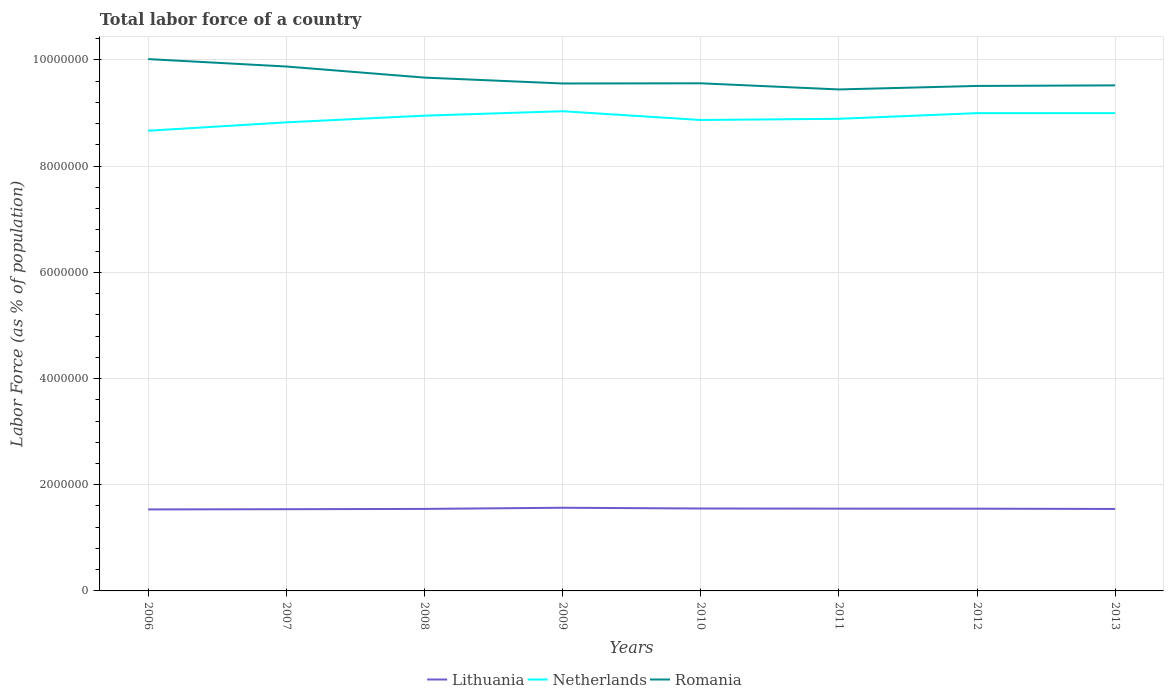Is the number of lines equal to the number of legend labels?
Give a very brief answer. Yes. Across all years, what is the maximum percentage of labor force in Netherlands?
Offer a very short reply. 8.67e+06. In which year was the percentage of labor force in Romania maximum?
Ensure brevity in your answer.  2011. What is the total percentage of labor force in Netherlands in the graph?
Offer a very short reply. 3.59e+04. What is the difference between the highest and the second highest percentage of labor force in Netherlands?
Provide a short and direct response. 3.68e+05. How many lines are there?
Your answer should be very brief. 3. What is the difference between two consecutive major ticks on the Y-axis?
Give a very brief answer. 2.00e+06. Are the values on the major ticks of Y-axis written in scientific E-notation?
Offer a very short reply. No. How many legend labels are there?
Ensure brevity in your answer.  3. How are the legend labels stacked?
Ensure brevity in your answer.  Horizontal. What is the title of the graph?
Keep it short and to the point. Total labor force of a country. What is the label or title of the X-axis?
Your answer should be compact. Years. What is the label or title of the Y-axis?
Your answer should be compact. Labor Force (as % of population). What is the Labor Force (as % of population) of Lithuania in 2006?
Keep it short and to the point. 1.53e+06. What is the Labor Force (as % of population) in Netherlands in 2006?
Give a very brief answer. 8.67e+06. What is the Labor Force (as % of population) in Romania in 2006?
Your answer should be very brief. 1.00e+07. What is the Labor Force (as % of population) of Lithuania in 2007?
Provide a succinct answer. 1.54e+06. What is the Labor Force (as % of population) of Netherlands in 2007?
Offer a terse response. 8.82e+06. What is the Labor Force (as % of population) in Romania in 2007?
Ensure brevity in your answer.  9.88e+06. What is the Labor Force (as % of population) in Lithuania in 2008?
Your answer should be very brief. 1.54e+06. What is the Labor Force (as % of population) of Netherlands in 2008?
Offer a very short reply. 8.95e+06. What is the Labor Force (as % of population) in Romania in 2008?
Make the answer very short. 9.67e+06. What is the Labor Force (as % of population) of Lithuania in 2009?
Your answer should be very brief. 1.57e+06. What is the Labor Force (as % of population) of Netherlands in 2009?
Ensure brevity in your answer.  9.03e+06. What is the Labor Force (as % of population) of Romania in 2009?
Provide a succinct answer. 9.56e+06. What is the Labor Force (as % of population) of Lithuania in 2010?
Keep it short and to the point. 1.55e+06. What is the Labor Force (as % of population) of Netherlands in 2010?
Your answer should be very brief. 8.87e+06. What is the Labor Force (as % of population) of Romania in 2010?
Your answer should be compact. 9.56e+06. What is the Labor Force (as % of population) in Lithuania in 2011?
Ensure brevity in your answer.  1.55e+06. What is the Labor Force (as % of population) in Netherlands in 2011?
Provide a succinct answer. 8.89e+06. What is the Labor Force (as % of population) in Romania in 2011?
Provide a succinct answer. 9.44e+06. What is the Labor Force (as % of population) of Lithuania in 2012?
Your answer should be compact. 1.55e+06. What is the Labor Force (as % of population) in Netherlands in 2012?
Your answer should be compact. 9.00e+06. What is the Labor Force (as % of population) in Romania in 2012?
Ensure brevity in your answer.  9.51e+06. What is the Labor Force (as % of population) in Lithuania in 2013?
Offer a very short reply. 1.54e+06. What is the Labor Force (as % of population) of Netherlands in 2013?
Ensure brevity in your answer.  9.00e+06. What is the Labor Force (as % of population) of Romania in 2013?
Ensure brevity in your answer.  9.52e+06. Across all years, what is the maximum Labor Force (as % of population) of Lithuania?
Keep it short and to the point. 1.57e+06. Across all years, what is the maximum Labor Force (as % of population) of Netherlands?
Offer a terse response. 9.03e+06. Across all years, what is the maximum Labor Force (as % of population) in Romania?
Your answer should be compact. 1.00e+07. Across all years, what is the minimum Labor Force (as % of population) of Lithuania?
Your answer should be very brief. 1.53e+06. Across all years, what is the minimum Labor Force (as % of population) of Netherlands?
Ensure brevity in your answer.  8.67e+06. Across all years, what is the minimum Labor Force (as % of population) in Romania?
Ensure brevity in your answer.  9.44e+06. What is the total Labor Force (as % of population) in Lithuania in the graph?
Offer a terse response. 1.24e+07. What is the total Labor Force (as % of population) in Netherlands in the graph?
Your answer should be very brief. 7.12e+07. What is the total Labor Force (as % of population) of Romania in the graph?
Make the answer very short. 7.72e+07. What is the difference between the Labor Force (as % of population) of Lithuania in 2006 and that in 2007?
Provide a short and direct response. -4175. What is the difference between the Labor Force (as % of population) in Netherlands in 2006 and that in 2007?
Offer a very short reply. -1.58e+05. What is the difference between the Labor Force (as % of population) of Romania in 2006 and that in 2007?
Give a very brief answer. 1.40e+05. What is the difference between the Labor Force (as % of population) in Lithuania in 2006 and that in 2008?
Offer a terse response. -9790. What is the difference between the Labor Force (as % of population) in Netherlands in 2006 and that in 2008?
Ensure brevity in your answer.  -2.84e+05. What is the difference between the Labor Force (as % of population) in Romania in 2006 and that in 2008?
Ensure brevity in your answer.  3.48e+05. What is the difference between the Labor Force (as % of population) of Lithuania in 2006 and that in 2009?
Keep it short and to the point. -3.15e+04. What is the difference between the Labor Force (as % of population) in Netherlands in 2006 and that in 2009?
Ensure brevity in your answer.  -3.68e+05. What is the difference between the Labor Force (as % of population) in Romania in 2006 and that in 2009?
Your response must be concise. 4.59e+05. What is the difference between the Labor Force (as % of population) in Lithuania in 2006 and that in 2010?
Provide a short and direct response. -1.74e+04. What is the difference between the Labor Force (as % of population) of Netherlands in 2006 and that in 2010?
Keep it short and to the point. -2.03e+05. What is the difference between the Labor Force (as % of population) of Romania in 2006 and that in 2010?
Provide a succinct answer. 4.56e+05. What is the difference between the Labor Force (as % of population) in Lithuania in 2006 and that in 2011?
Make the answer very short. -1.46e+04. What is the difference between the Labor Force (as % of population) in Netherlands in 2006 and that in 2011?
Keep it short and to the point. -2.25e+05. What is the difference between the Labor Force (as % of population) in Romania in 2006 and that in 2011?
Provide a short and direct response. 5.72e+05. What is the difference between the Labor Force (as % of population) of Lithuania in 2006 and that in 2012?
Make the answer very short. -1.38e+04. What is the difference between the Labor Force (as % of population) of Netherlands in 2006 and that in 2012?
Give a very brief answer. -3.32e+05. What is the difference between the Labor Force (as % of population) of Romania in 2006 and that in 2012?
Make the answer very short. 5.06e+05. What is the difference between the Labor Force (as % of population) of Lithuania in 2006 and that in 2013?
Provide a succinct answer. -8868. What is the difference between the Labor Force (as % of population) in Netherlands in 2006 and that in 2013?
Keep it short and to the point. -3.32e+05. What is the difference between the Labor Force (as % of population) in Romania in 2006 and that in 2013?
Offer a very short reply. 4.95e+05. What is the difference between the Labor Force (as % of population) in Lithuania in 2007 and that in 2008?
Give a very brief answer. -5615. What is the difference between the Labor Force (as % of population) in Netherlands in 2007 and that in 2008?
Your answer should be compact. -1.26e+05. What is the difference between the Labor Force (as % of population) of Romania in 2007 and that in 2008?
Your response must be concise. 2.09e+05. What is the difference between the Labor Force (as % of population) in Lithuania in 2007 and that in 2009?
Your answer should be very brief. -2.74e+04. What is the difference between the Labor Force (as % of population) in Netherlands in 2007 and that in 2009?
Your answer should be very brief. -2.10e+05. What is the difference between the Labor Force (as % of population) in Romania in 2007 and that in 2009?
Keep it short and to the point. 3.20e+05. What is the difference between the Labor Force (as % of population) of Lithuania in 2007 and that in 2010?
Your answer should be compact. -1.32e+04. What is the difference between the Labor Force (as % of population) in Netherlands in 2007 and that in 2010?
Offer a terse response. -4.43e+04. What is the difference between the Labor Force (as % of population) in Romania in 2007 and that in 2010?
Provide a succinct answer. 3.16e+05. What is the difference between the Labor Force (as % of population) in Lithuania in 2007 and that in 2011?
Provide a short and direct response. -1.04e+04. What is the difference between the Labor Force (as % of population) of Netherlands in 2007 and that in 2011?
Make the answer very short. -6.68e+04. What is the difference between the Labor Force (as % of population) in Romania in 2007 and that in 2011?
Give a very brief answer. 4.32e+05. What is the difference between the Labor Force (as % of population) of Lithuania in 2007 and that in 2012?
Give a very brief answer. -9575. What is the difference between the Labor Force (as % of population) of Netherlands in 2007 and that in 2012?
Give a very brief answer. -1.73e+05. What is the difference between the Labor Force (as % of population) in Romania in 2007 and that in 2012?
Offer a very short reply. 3.66e+05. What is the difference between the Labor Force (as % of population) of Lithuania in 2007 and that in 2013?
Offer a very short reply. -4693. What is the difference between the Labor Force (as % of population) of Netherlands in 2007 and that in 2013?
Keep it short and to the point. -1.74e+05. What is the difference between the Labor Force (as % of population) of Romania in 2007 and that in 2013?
Provide a succinct answer. 3.55e+05. What is the difference between the Labor Force (as % of population) in Lithuania in 2008 and that in 2009?
Provide a short and direct response. -2.17e+04. What is the difference between the Labor Force (as % of population) of Netherlands in 2008 and that in 2009?
Ensure brevity in your answer.  -8.38e+04. What is the difference between the Labor Force (as % of population) in Romania in 2008 and that in 2009?
Give a very brief answer. 1.11e+05. What is the difference between the Labor Force (as % of population) of Lithuania in 2008 and that in 2010?
Your answer should be compact. -7584. What is the difference between the Labor Force (as % of population) of Netherlands in 2008 and that in 2010?
Provide a short and direct response. 8.14e+04. What is the difference between the Labor Force (as % of population) of Romania in 2008 and that in 2010?
Your answer should be very brief. 1.08e+05. What is the difference between the Labor Force (as % of population) of Lithuania in 2008 and that in 2011?
Offer a terse response. -4782. What is the difference between the Labor Force (as % of population) of Netherlands in 2008 and that in 2011?
Provide a short and direct response. 5.89e+04. What is the difference between the Labor Force (as % of population) in Romania in 2008 and that in 2011?
Your answer should be compact. 2.23e+05. What is the difference between the Labor Force (as % of population) in Lithuania in 2008 and that in 2012?
Your answer should be compact. -3960. What is the difference between the Labor Force (as % of population) of Netherlands in 2008 and that in 2012?
Your answer should be very brief. -4.76e+04. What is the difference between the Labor Force (as % of population) of Romania in 2008 and that in 2012?
Your response must be concise. 1.57e+05. What is the difference between the Labor Force (as % of population) of Lithuania in 2008 and that in 2013?
Your answer should be very brief. 922. What is the difference between the Labor Force (as % of population) in Netherlands in 2008 and that in 2013?
Give a very brief answer. -4.79e+04. What is the difference between the Labor Force (as % of population) of Romania in 2008 and that in 2013?
Make the answer very short. 1.47e+05. What is the difference between the Labor Force (as % of population) in Lithuania in 2009 and that in 2010?
Ensure brevity in your answer.  1.42e+04. What is the difference between the Labor Force (as % of population) of Netherlands in 2009 and that in 2010?
Offer a very short reply. 1.65e+05. What is the difference between the Labor Force (as % of population) in Romania in 2009 and that in 2010?
Your answer should be very brief. -3468. What is the difference between the Labor Force (as % of population) of Lithuania in 2009 and that in 2011?
Ensure brevity in your answer.  1.70e+04. What is the difference between the Labor Force (as % of population) of Netherlands in 2009 and that in 2011?
Offer a terse response. 1.43e+05. What is the difference between the Labor Force (as % of population) of Romania in 2009 and that in 2011?
Your answer should be compact. 1.12e+05. What is the difference between the Labor Force (as % of population) of Lithuania in 2009 and that in 2012?
Offer a terse response. 1.78e+04. What is the difference between the Labor Force (as % of population) in Netherlands in 2009 and that in 2012?
Provide a succinct answer. 3.62e+04. What is the difference between the Labor Force (as % of population) in Romania in 2009 and that in 2012?
Keep it short and to the point. 4.61e+04. What is the difference between the Labor Force (as % of population) of Lithuania in 2009 and that in 2013?
Your answer should be compact. 2.27e+04. What is the difference between the Labor Force (as % of population) of Netherlands in 2009 and that in 2013?
Offer a very short reply. 3.59e+04. What is the difference between the Labor Force (as % of population) of Romania in 2009 and that in 2013?
Keep it short and to the point. 3.56e+04. What is the difference between the Labor Force (as % of population) in Lithuania in 2010 and that in 2011?
Your response must be concise. 2802. What is the difference between the Labor Force (as % of population) of Netherlands in 2010 and that in 2011?
Give a very brief answer. -2.25e+04. What is the difference between the Labor Force (as % of population) of Romania in 2010 and that in 2011?
Keep it short and to the point. 1.16e+05. What is the difference between the Labor Force (as % of population) of Lithuania in 2010 and that in 2012?
Offer a very short reply. 3624. What is the difference between the Labor Force (as % of population) of Netherlands in 2010 and that in 2012?
Provide a short and direct response. -1.29e+05. What is the difference between the Labor Force (as % of population) of Romania in 2010 and that in 2012?
Keep it short and to the point. 4.96e+04. What is the difference between the Labor Force (as % of population) in Lithuania in 2010 and that in 2013?
Provide a short and direct response. 8506. What is the difference between the Labor Force (as % of population) of Netherlands in 2010 and that in 2013?
Provide a succinct answer. -1.29e+05. What is the difference between the Labor Force (as % of population) of Romania in 2010 and that in 2013?
Your answer should be very brief. 3.90e+04. What is the difference between the Labor Force (as % of population) in Lithuania in 2011 and that in 2012?
Your answer should be compact. 822. What is the difference between the Labor Force (as % of population) of Netherlands in 2011 and that in 2012?
Provide a short and direct response. -1.07e+05. What is the difference between the Labor Force (as % of population) in Romania in 2011 and that in 2012?
Offer a very short reply. -6.60e+04. What is the difference between the Labor Force (as % of population) of Lithuania in 2011 and that in 2013?
Give a very brief answer. 5704. What is the difference between the Labor Force (as % of population) in Netherlands in 2011 and that in 2013?
Give a very brief answer. -1.07e+05. What is the difference between the Labor Force (as % of population) of Romania in 2011 and that in 2013?
Provide a short and direct response. -7.65e+04. What is the difference between the Labor Force (as % of population) in Lithuania in 2012 and that in 2013?
Offer a terse response. 4882. What is the difference between the Labor Force (as % of population) of Netherlands in 2012 and that in 2013?
Offer a very short reply. -260. What is the difference between the Labor Force (as % of population) in Romania in 2012 and that in 2013?
Make the answer very short. -1.06e+04. What is the difference between the Labor Force (as % of population) of Lithuania in 2006 and the Labor Force (as % of population) of Netherlands in 2007?
Your answer should be compact. -7.29e+06. What is the difference between the Labor Force (as % of population) of Lithuania in 2006 and the Labor Force (as % of population) of Romania in 2007?
Offer a terse response. -8.34e+06. What is the difference between the Labor Force (as % of population) of Netherlands in 2006 and the Labor Force (as % of population) of Romania in 2007?
Offer a terse response. -1.21e+06. What is the difference between the Labor Force (as % of population) in Lithuania in 2006 and the Labor Force (as % of population) in Netherlands in 2008?
Provide a short and direct response. -7.42e+06. What is the difference between the Labor Force (as % of population) of Lithuania in 2006 and the Labor Force (as % of population) of Romania in 2008?
Ensure brevity in your answer.  -8.13e+06. What is the difference between the Labor Force (as % of population) of Netherlands in 2006 and the Labor Force (as % of population) of Romania in 2008?
Your response must be concise. -1.00e+06. What is the difference between the Labor Force (as % of population) of Lithuania in 2006 and the Labor Force (as % of population) of Netherlands in 2009?
Provide a short and direct response. -7.50e+06. What is the difference between the Labor Force (as % of population) in Lithuania in 2006 and the Labor Force (as % of population) in Romania in 2009?
Keep it short and to the point. -8.02e+06. What is the difference between the Labor Force (as % of population) in Netherlands in 2006 and the Labor Force (as % of population) in Romania in 2009?
Your answer should be very brief. -8.90e+05. What is the difference between the Labor Force (as % of population) of Lithuania in 2006 and the Labor Force (as % of population) of Netherlands in 2010?
Make the answer very short. -7.33e+06. What is the difference between the Labor Force (as % of population) in Lithuania in 2006 and the Labor Force (as % of population) in Romania in 2010?
Make the answer very short. -8.02e+06. What is the difference between the Labor Force (as % of population) of Netherlands in 2006 and the Labor Force (as % of population) of Romania in 2010?
Give a very brief answer. -8.93e+05. What is the difference between the Labor Force (as % of population) in Lithuania in 2006 and the Labor Force (as % of population) in Netherlands in 2011?
Ensure brevity in your answer.  -7.36e+06. What is the difference between the Labor Force (as % of population) in Lithuania in 2006 and the Labor Force (as % of population) in Romania in 2011?
Offer a very short reply. -7.91e+06. What is the difference between the Labor Force (as % of population) in Netherlands in 2006 and the Labor Force (as % of population) in Romania in 2011?
Your response must be concise. -7.78e+05. What is the difference between the Labor Force (as % of population) of Lithuania in 2006 and the Labor Force (as % of population) of Netherlands in 2012?
Your answer should be very brief. -7.46e+06. What is the difference between the Labor Force (as % of population) of Lithuania in 2006 and the Labor Force (as % of population) of Romania in 2012?
Provide a succinct answer. -7.98e+06. What is the difference between the Labor Force (as % of population) in Netherlands in 2006 and the Labor Force (as % of population) in Romania in 2012?
Give a very brief answer. -8.44e+05. What is the difference between the Labor Force (as % of population) of Lithuania in 2006 and the Labor Force (as % of population) of Netherlands in 2013?
Make the answer very short. -7.46e+06. What is the difference between the Labor Force (as % of population) of Lithuania in 2006 and the Labor Force (as % of population) of Romania in 2013?
Your answer should be very brief. -7.99e+06. What is the difference between the Labor Force (as % of population) in Netherlands in 2006 and the Labor Force (as % of population) in Romania in 2013?
Ensure brevity in your answer.  -8.54e+05. What is the difference between the Labor Force (as % of population) of Lithuania in 2007 and the Labor Force (as % of population) of Netherlands in 2008?
Keep it short and to the point. -7.41e+06. What is the difference between the Labor Force (as % of population) in Lithuania in 2007 and the Labor Force (as % of population) in Romania in 2008?
Offer a very short reply. -8.13e+06. What is the difference between the Labor Force (as % of population) of Netherlands in 2007 and the Labor Force (as % of population) of Romania in 2008?
Provide a succinct answer. -8.43e+05. What is the difference between the Labor Force (as % of population) in Lithuania in 2007 and the Labor Force (as % of population) in Netherlands in 2009?
Give a very brief answer. -7.50e+06. What is the difference between the Labor Force (as % of population) in Lithuania in 2007 and the Labor Force (as % of population) in Romania in 2009?
Provide a short and direct response. -8.02e+06. What is the difference between the Labor Force (as % of population) in Netherlands in 2007 and the Labor Force (as % of population) in Romania in 2009?
Give a very brief answer. -7.32e+05. What is the difference between the Labor Force (as % of population) of Lithuania in 2007 and the Labor Force (as % of population) of Netherlands in 2010?
Offer a very short reply. -7.33e+06. What is the difference between the Labor Force (as % of population) of Lithuania in 2007 and the Labor Force (as % of population) of Romania in 2010?
Make the answer very short. -8.02e+06. What is the difference between the Labor Force (as % of population) in Netherlands in 2007 and the Labor Force (as % of population) in Romania in 2010?
Provide a succinct answer. -7.35e+05. What is the difference between the Labor Force (as % of population) of Lithuania in 2007 and the Labor Force (as % of population) of Netherlands in 2011?
Offer a very short reply. -7.35e+06. What is the difference between the Labor Force (as % of population) of Lithuania in 2007 and the Labor Force (as % of population) of Romania in 2011?
Provide a succinct answer. -7.91e+06. What is the difference between the Labor Force (as % of population) in Netherlands in 2007 and the Labor Force (as % of population) in Romania in 2011?
Keep it short and to the point. -6.20e+05. What is the difference between the Labor Force (as % of population) in Lithuania in 2007 and the Labor Force (as % of population) in Netherlands in 2012?
Your answer should be compact. -7.46e+06. What is the difference between the Labor Force (as % of population) in Lithuania in 2007 and the Labor Force (as % of population) in Romania in 2012?
Provide a short and direct response. -7.97e+06. What is the difference between the Labor Force (as % of population) in Netherlands in 2007 and the Labor Force (as % of population) in Romania in 2012?
Your response must be concise. -6.86e+05. What is the difference between the Labor Force (as % of population) in Lithuania in 2007 and the Labor Force (as % of population) in Netherlands in 2013?
Keep it short and to the point. -7.46e+06. What is the difference between the Labor Force (as % of population) in Lithuania in 2007 and the Labor Force (as % of population) in Romania in 2013?
Offer a terse response. -7.98e+06. What is the difference between the Labor Force (as % of population) of Netherlands in 2007 and the Labor Force (as % of population) of Romania in 2013?
Your answer should be compact. -6.96e+05. What is the difference between the Labor Force (as % of population) in Lithuania in 2008 and the Labor Force (as % of population) in Netherlands in 2009?
Offer a very short reply. -7.49e+06. What is the difference between the Labor Force (as % of population) in Lithuania in 2008 and the Labor Force (as % of population) in Romania in 2009?
Offer a terse response. -8.01e+06. What is the difference between the Labor Force (as % of population) of Netherlands in 2008 and the Labor Force (as % of population) of Romania in 2009?
Your response must be concise. -6.06e+05. What is the difference between the Labor Force (as % of population) in Lithuania in 2008 and the Labor Force (as % of population) in Netherlands in 2010?
Your response must be concise. -7.32e+06. What is the difference between the Labor Force (as % of population) in Lithuania in 2008 and the Labor Force (as % of population) in Romania in 2010?
Offer a very short reply. -8.02e+06. What is the difference between the Labor Force (as % of population) in Netherlands in 2008 and the Labor Force (as % of population) in Romania in 2010?
Your answer should be very brief. -6.09e+05. What is the difference between the Labor Force (as % of population) of Lithuania in 2008 and the Labor Force (as % of population) of Netherlands in 2011?
Your response must be concise. -7.35e+06. What is the difference between the Labor Force (as % of population) in Lithuania in 2008 and the Labor Force (as % of population) in Romania in 2011?
Provide a short and direct response. -7.90e+06. What is the difference between the Labor Force (as % of population) of Netherlands in 2008 and the Labor Force (as % of population) of Romania in 2011?
Keep it short and to the point. -4.94e+05. What is the difference between the Labor Force (as % of population) of Lithuania in 2008 and the Labor Force (as % of population) of Netherlands in 2012?
Provide a succinct answer. -7.45e+06. What is the difference between the Labor Force (as % of population) in Lithuania in 2008 and the Labor Force (as % of population) in Romania in 2012?
Provide a succinct answer. -7.97e+06. What is the difference between the Labor Force (as % of population) in Netherlands in 2008 and the Labor Force (as % of population) in Romania in 2012?
Provide a short and direct response. -5.60e+05. What is the difference between the Labor Force (as % of population) in Lithuania in 2008 and the Labor Force (as % of population) in Netherlands in 2013?
Offer a very short reply. -7.45e+06. What is the difference between the Labor Force (as % of population) of Lithuania in 2008 and the Labor Force (as % of population) of Romania in 2013?
Ensure brevity in your answer.  -7.98e+06. What is the difference between the Labor Force (as % of population) of Netherlands in 2008 and the Labor Force (as % of population) of Romania in 2013?
Your answer should be very brief. -5.70e+05. What is the difference between the Labor Force (as % of population) in Lithuania in 2009 and the Labor Force (as % of population) in Netherlands in 2010?
Keep it short and to the point. -7.30e+06. What is the difference between the Labor Force (as % of population) in Lithuania in 2009 and the Labor Force (as % of population) in Romania in 2010?
Provide a succinct answer. -7.99e+06. What is the difference between the Labor Force (as % of population) of Netherlands in 2009 and the Labor Force (as % of population) of Romania in 2010?
Your response must be concise. -5.26e+05. What is the difference between the Labor Force (as % of population) of Lithuania in 2009 and the Labor Force (as % of population) of Netherlands in 2011?
Offer a terse response. -7.33e+06. What is the difference between the Labor Force (as % of population) in Lithuania in 2009 and the Labor Force (as % of population) in Romania in 2011?
Offer a very short reply. -7.88e+06. What is the difference between the Labor Force (as % of population) of Netherlands in 2009 and the Labor Force (as % of population) of Romania in 2011?
Ensure brevity in your answer.  -4.10e+05. What is the difference between the Labor Force (as % of population) in Lithuania in 2009 and the Labor Force (as % of population) in Netherlands in 2012?
Give a very brief answer. -7.43e+06. What is the difference between the Labor Force (as % of population) of Lithuania in 2009 and the Labor Force (as % of population) of Romania in 2012?
Ensure brevity in your answer.  -7.94e+06. What is the difference between the Labor Force (as % of population) of Netherlands in 2009 and the Labor Force (as % of population) of Romania in 2012?
Keep it short and to the point. -4.76e+05. What is the difference between the Labor Force (as % of population) of Lithuania in 2009 and the Labor Force (as % of population) of Netherlands in 2013?
Your response must be concise. -7.43e+06. What is the difference between the Labor Force (as % of population) of Lithuania in 2009 and the Labor Force (as % of population) of Romania in 2013?
Give a very brief answer. -7.95e+06. What is the difference between the Labor Force (as % of population) in Netherlands in 2009 and the Labor Force (as % of population) in Romania in 2013?
Provide a succinct answer. -4.87e+05. What is the difference between the Labor Force (as % of population) in Lithuania in 2010 and the Labor Force (as % of population) in Netherlands in 2011?
Provide a short and direct response. -7.34e+06. What is the difference between the Labor Force (as % of population) of Lithuania in 2010 and the Labor Force (as % of population) of Romania in 2011?
Keep it short and to the point. -7.89e+06. What is the difference between the Labor Force (as % of population) of Netherlands in 2010 and the Labor Force (as % of population) of Romania in 2011?
Provide a succinct answer. -5.75e+05. What is the difference between the Labor Force (as % of population) in Lithuania in 2010 and the Labor Force (as % of population) in Netherlands in 2012?
Make the answer very short. -7.45e+06. What is the difference between the Labor Force (as % of population) of Lithuania in 2010 and the Labor Force (as % of population) of Romania in 2012?
Make the answer very short. -7.96e+06. What is the difference between the Labor Force (as % of population) of Netherlands in 2010 and the Labor Force (as % of population) of Romania in 2012?
Provide a short and direct response. -6.41e+05. What is the difference between the Labor Force (as % of population) of Lithuania in 2010 and the Labor Force (as % of population) of Netherlands in 2013?
Ensure brevity in your answer.  -7.45e+06. What is the difference between the Labor Force (as % of population) in Lithuania in 2010 and the Labor Force (as % of population) in Romania in 2013?
Your answer should be very brief. -7.97e+06. What is the difference between the Labor Force (as % of population) of Netherlands in 2010 and the Labor Force (as % of population) of Romania in 2013?
Provide a succinct answer. -6.52e+05. What is the difference between the Labor Force (as % of population) of Lithuania in 2011 and the Labor Force (as % of population) of Netherlands in 2012?
Make the answer very short. -7.45e+06. What is the difference between the Labor Force (as % of population) in Lithuania in 2011 and the Labor Force (as % of population) in Romania in 2012?
Keep it short and to the point. -7.96e+06. What is the difference between the Labor Force (as % of population) of Netherlands in 2011 and the Labor Force (as % of population) of Romania in 2012?
Offer a very short reply. -6.19e+05. What is the difference between the Labor Force (as % of population) of Lithuania in 2011 and the Labor Force (as % of population) of Netherlands in 2013?
Ensure brevity in your answer.  -7.45e+06. What is the difference between the Labor Force (as % of population) in Lithuania in 2011 and the Labor Force (as % of population) in Romania in 2013?
Offer a very short reply. -7.97e+06. What is the difference between the Labor Force (as % of population) in Netherlands in 2011 and the Labor Force (as % of population) in Romania in 2013?
Give a very brief answer. -6.29e+05. What is the difference between the Labor Force (as % of population) of Lithuania in 2012 and the Labor Force (as % of population) of Netherlands in 2013?
Ensure brevity in your answer.  -7.45e+06. What is the difference between the Labor Force (as % of population) in Lithuania in 2012 and the Labor Force (as % of population) in Romania in 2013?
Offer a very short reply. -7.97e+06. What is the difference between the Labor Force (as % of population) in Netherlands in 2012 and the Labor Force (as % of population) in Romania in 2013?
Provide a short and direct response. -5.23e+05. What is the average Labor Force (as % of population) of Lithuania per year?
Provide a short and direct response. 1.55e+06. What is the average Labor Force (as % of population) in Netherlands per year?
Keep it short and to the point. 8.90e+06. What is the average Labor Force (as % of population) in Romania per year?
Keep it short and to the point. 9.64e+06. In the year 2006, what is the difference between the Labor Force (as % of population) in Lithuania and Labor Force (as % of population) in Netherlands?
Keep it short and to the point. -7.13e+06. In the year 2006, what is the difference between the Labor Force (as % of population) of Lithuania and Labor Force (as % of population) of Romania?
Offer a terse response. -8.48e+06. In the year 2006, what is the difference between the Labor Force (as % of population) in Netherlands and Labor Force (as % of population) in Romania?
Provide a short and direct response. -1.35e+06. In the year 2007, what is the difference between the Labor Force (as % of population) in Lithuania and Labor Force (as % of population) in Netherlands?
Provide a short and direct response. -7.29e+06. In the year 2007, what is the difference between the Labor Force (as % of population) of Lithuania and Labor Force (as % of population) of Romania?
Keep it short and to the point. -8.34e+06. In the year 2007, what is the difference between the Labor Force (as % of population) of Netherlands and Labor Force (as % of population) of Romania?
Offer a terse response. -1.05e+06. In the year 2008, what is the difference between the Labor Force (as % of population) of Lithuania and Labor Force (as % of population) of Netherlands?
Your answer should be very brief. -7.41e+06. In the year 2008, what is the difference between the Labor Force (as % of population) in Lithuania and Labor Force (as % of population) in Romania?
Your answer should be compact. -8.12e+06. In the year 2008, what is the difference between the Labor Force (as % of population) in Netherlands and Labor Force (as % of population) in Romania?
Your response must be concise. -7.17e+05. In the year 2009, what is the difference between the Labor Force (as % of population) of Lithuania and Labor Force (as % of population) of Netherlands?
Your answer should be very brief. -7.47e+06. In the year 2009, what is the difference between the Labor Force (as % of population) in Lithuania and Labor Force (as % of population) in Romania?
Your answer should be very brief. -7.99e+06. In the year 2009, what is the difference between the Labor Force (as % of population) in Netherlands and Labor Force (as % of population) in Romania?
Provide a short and direct response. -5.22e+05. In the year 2010, what is the difference between the Labor Force (as % of population) of Lithuania and Labor Force (as % of population) of Netherlands?
Offer a very short reply. -7.32e+06. In the year 2010, what is the difference between the Labor Force (as % of population) of Lithuania and Labor Force (as % of population) of Romania?
Give a very brief answer. -8.01e+06. In the year 2010, what is the difference between the Labor Force (as % of population) of Netherlands and Labor Force (as % of population) of Romania?
Keep it short and to the point. -6.91e+05. In the year 2011, what is the difference between the Labor Force (as % of population) in Lithuania and Labor Force (as % of population) in Netherlands?
Make the answer very short. -7.34e+06. In the year 2011, what is the difference between the Labor Force (as % of population) in Lithuania and Labor Force (as % of population) in Romania?
Give a very brief answer. -7.89e+06. In the year 2011, what is the difference between the Labor Force (as % of population) in Netherlands and Labor Force (as % of population) in Romania?
Your answer should be very brief. -5.53e+05. In the year 2012, what is the difference between the Labor Force (as % of population) in Lithuania and Labor Force (as % of population) in Netherlands?
Your answer should be very brief. -7.45e+06. In the year 2012, what is the difference between the Labor Force (as % of population) in Lithuania and Labor Force (as % of population) in Romania?
Provide a succinct answer. -7.96e+06. In the year 2012, what is the difference between the Labor Force (as % of population) in Netherlands and Labor Force (as % of population) in Romania?
Keep it short and to the point. -5.12e+05. In the year 2013, what is the difference between the Labor Force (as % of population) of Lithuania and Labor Force (as % of population) of Netherlands?
Offer a terse response. -7.45e+06. In the year 2013, what is the difference between the Labor Force (as % of population) in Lithuania and Labor Force (as % of population) in Romania?
Make the answer very short. -7.98e+06. In the year 2013, what is the difference between the Labor Force (as % of population) in Netherlands and Labor Force (as % of population) in Romania?
Your answer should be very brief. -5.23e+05. What is the ratio of the Labor Force (as % of population) of Lithuania in 2006 to that in 2007?
Your answer should be very brief. 1. What is the ratio of the Labor Force (as % of population) of Netherlands in 2006 to that in 2007?
Keep it short and to the point. 0.98. What is the ratio of the Labor Force (as % of population) of Romania in 2006 to that in 2007?
Your answer should be very brief. 1.01. What is the ratio of the Labor Force (as % of population) in Lithuania in 2006 to that in 2008?
Offer a very short reply. 0.99. What is the ratio of the Labor Force (as % of population) in Netherlands in 2006 to that in 2008?
Provide a short and direct response. 0.97. What is the ratio of the Labor Force (as % of population) of Romania in 2006 to that in 2008?
Give a very brief answer. 1.04. What is the ratio of the Labor Force (as % of population) of Lithuania in 2006 to that in 2009?
Your answer should be very brief. 0.98. What is the ratio of the Labor Force (as % of population) of Netherlands in 2006 to that in 2009?
Your answer should be compact. 0.96. What is the ratio of the Labor Force (as % of population) in Romania in 2006 to that in 2009?
Offer a very short reply. 1.05. What is the ratio of the Labor Force (as % of population) in Netherlands in 2006 to that in 2010?
Your response must be concise. 0.98. What is the ratio of the Labor Force (as % of population) of Romania in 2006 to that in 2010?
Keep it short and to the point. 1.05. What is the ratio of the Labor Force (as % of population) in Lithuania in 2006 to that in 2011?
Your response must be concise. 0.99. What is the ratio of the Labor Force (as % of population) of Netherlands in 2006 to that in 2011?
Keep it short and to the point. 0.97. What is the ratio of the Labor Force (as % of population) of Romania in 2006 to that in 2011?
Give a very brief answer. 1.06. What is the ratio of the Labor Force (as % of population) of Lithuania in 2006 to that in 2012?
Ensure brevity in your answer.  0.99. What is the ratio of the Labor Force (as % of population) in Netherlands in 2006 to that in 2012?
Keep it short and to the point. 0.96. What is the ratio of the Labor Force (as % of population) of Romania in 2006 to that in 2012?
Your answer should be very brief. 1.05. What is the ratio of the Labor Force (as % of population) of Netherlands in 2006 to that in 2013?
Provide a succinct answer. 0.96. What is the ratio of the Labor Force (as % of population) of Romania in 2006 to that in 2013?
Your answer should be very brief. 1.05. What is the ratio of the Labor Force (as % of population) in Lithuania in 2007 to that in 2008?
Your answer should be compact. 1. What is the ratio of the Labor Force (as % of population) in Romania in 2007 to that in 2008?
Keep it short and to the point. 1.02. What is the ratio of the Labor Force (as % of population) in Lithuania in 2007 to that in 2009?
Provide a short and direct response. 0.98. What is the ratio of the Labor Force (as % of population) in Netherlands in 2007 to that in 2009?
Provide a succinct answer. 0.98. What is the ratio of the Labor Force (as % of population) in Romania in 2007 to that in 2009?
Provide a succinct answer. 1.03. What is the ratio of the Labor Force (as % of population) of Netherlands in 2007 to that in 2010?
Offer a very short reply. 0.99. What is the ratio of the Labor Force (as % of population) of Romania in 2007 to that in 2010?
Offer a very short reply. 1.03. What is the ratio of the Labor Force (as % of population) of Netherlands in 2007 to that in 2011?
Ensure brevity in your answer.  0.99. What is the ratio of the Labor Force (as % of population) of Romania in 2007 to that in 2011?
Give a very brief answer. 1.05. What is the ratio of the Labor Force (as % of population) of Lithuania in 2007 to that in 2012?
Provide a succinct answer. 0.99. What is the ratio of the Labor Force (as % of population) of Netherlands in 2007 to that in 2012?
Ensure brevity in your answer.  0.98. What is the ratio of the Labor Force (as % of population) in Romania in 2007 to that in 2012?
Ensure brevity in your answer.  1.04. What is the ratio of the Labor Force (as % of population) of Lithuania in 2007 to that in 2013?
Provide a succinct answer. 1. What is the ratio of the Labor Force (as % of population) of Netherlands in 2007 to that in 2013?
Keep it short and to the point. 0.98. What is the ratio of the Labor Force (as % of population) in Romania in 2007 to that in 2013?
Your response must be concise. 1.04. What is the ratio of the Labor Force (as % of population) in Lithuania in 2008 to that in 2009?
Provide a succinct answer. 0.99. What is the ratio of the Labor Force (as % of population) of Romania in 2008 to that in 2009?
Provide a succinct answer. 1.01. What is the ratio of the Labor Force (as % of population) in Lithuania in 2008 to that in 2010?
Ensure brevity in your answer.  1. What is the ratio of the Labor Force (as % of population) in Netherlands in 2008 to that in 2010?
Ensure brevity in your answer.  1.01. What is the ratio of the Labor Force (as % of population) in Romania in 2008 to that in 2010?
Provide a succinct answer. 1.01. What is the ratio of the Labor Force (as % of population) of Netherlands in 2008 to that in 2011?
Keep it short and to the point. 1.01. What is the ratio of the Labor Force (as % of population) in Romania in 2008 to that in 2011?
Provide a succinct answer. 1.02. What is the ratio of the Labor Force (as % of population) of Netherlands in 2008 to that in 2012?
Ensure brevity in your answer.  0.99. What is the ratio of the Labor Force (as % of population) of Romania in 2008 to that in 2012?
Your answer should be very brief. 1.02. What is the ratio of the Labor Force (as % of population) of Lithuania in 2008 to that in 2013?
Provide a succinct answer. 1. What is the ratio of the Labor Force (as % of population) of Romania in 2008 to that in 2013?
Make the answer very short. 1.02. What is the ratio of the Labor Force (as % of population) in Lithuania in 2009 to that in 2010?
Your response must be concise. 1.01. What is the ratio of the Labor Force (as % of population) in Netherlands in 2009 to that in 2010?
Your answer should be very brief. 1.02. What is the ratio of the Labor Force (as % of population) of Romania in 2009 to that in 2010?
Your answer should be very brief. 1. What is the ratio of the Labor Force (as % of population) of Lithuania in 2009 to that in 2011?
Keep it short and to the point. 1.01. What is the ratio of the Labor Force (as % of population) of Netherlands in 2009 to that in 2011?
Offer a very short reply. 1.02. What is the ratio of the Labor Force (as % of population) in Romania in 2009 to that in 2011?
Offer a very short reply. 1.01. What is the ratio of the Labor Force (as % of population) in Lithuania in 2009 to that in 2012?
Your answer should be compact. 1.01. What is the ratio of the Labor Force (as % of population) in Romania in 2009 to that in 2012?
Ensure brevity in your answer.  1. What is the ratio of the Labor Force (as % of population) of Lithuania in 2009 to that in 2013?
Offer a terse response. 1.01. What is the ratio of the Labor Force (as % of population) in Netherlands in 2009 to that in 2013?
Make the answer very short. 1. What is the ratio of the Labor Force (as % of population) in Romania in 2009 to that in 2013?
Your response must be concise. 1. What is the ratio of the Labor Force (as % of population) in Lithuania in 2010 to that in 2011?
Provide a short and direct response. 1. What is the ratio of the Labor Force (as % of population) of Netherlands in 2010 to that in 2011?
Offer a very short reply. 1. What is the ratio of the Labor Force (as % of population) in Romania in 2010 to that in 2011?
Make the answer very short. 1.01. What is the ratio of the Labor Force (as % of population) in Netherlands in 2010 to that in 2012?
Your answer should be very brief. 0.99. What is the ratio of the Labor Force (as % of population) of Romania in 2010 to that in 2012?
Ensure brevity in your answer.  1.01. What is the ratio of the Labor Force (as % of population) in Lithuania in 2010 to that in 2013?
Your answer should be very brief. 1.01. What is the ratio of the Labor Force (as % of population) in Netherlands in 2010 to that in 2013?
Ensure brevity in your answer.  0.99. What is the ratio of the Labor Force (as % of population) of Lithuania in 2011 to that in 2012?
Offer a very short reply. 1. What is the ratio of the Labor Force (as % of population) of Romania in 2011 to that in 2012?
Your answer should be very brief. 0.99. What is the ratio of the Labor Force (as % of population) in Netherlands in 2011 to that in 2013?
Offer a very short reply. 0.99. What is the ratio of the Labor Force (as % of population) of Romania in 2012 to that in 2013?
Provide a succinct answer. 1. What is the difference between the highest and the second highest Labor Force (as % of population) in Lithuania?
Your response must be concise. 1.42e+04. What is the difference between the highest and the second highest Labor Force (as % of population) of Netherlands?
Your answer should be compact. 3.59e+04. What is the difference between the highest and the second highest Labor Force (as % of population) in Romania?
Your response must be concise. 1.40e+05. What is the difference between the highest and the lowest Labor Force (as % of population) of Lithuania?
Make the answer very short. 3.15e+04. What is the difference between the highest and the lowest Labor Force (as % of population) of Netherlands?
Your answer should be very brief. 3.68e+05. What is the difference between the highest and the lowest Labor Force (as % of population) of Romania?
Give a very brief answer. 5.72e+05. 